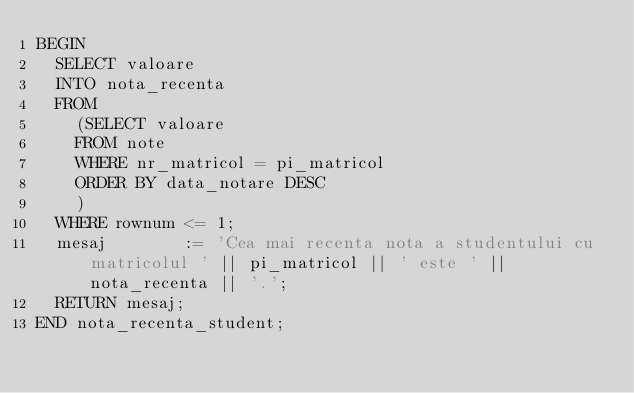<code> <loc_0><loc_0><loc_500><loc_500><_SQL_>BEGIN
  SELECT valoare
  INTO nota_recenta
  FROM
    (SELECT valoare
    FROM note
    WHERE nr_matricol = pi_matricol
    ORDER BY data_notare DESC
    )
  WHERE rownum <= 1;
  mesaj        := 'Cea mai recenta nota a studentului cu matricolul ' || pi_matricol || ' este ' || nota_recenta || '.';
  RETURN mesaj;
END nota_recenta_student;</code> 